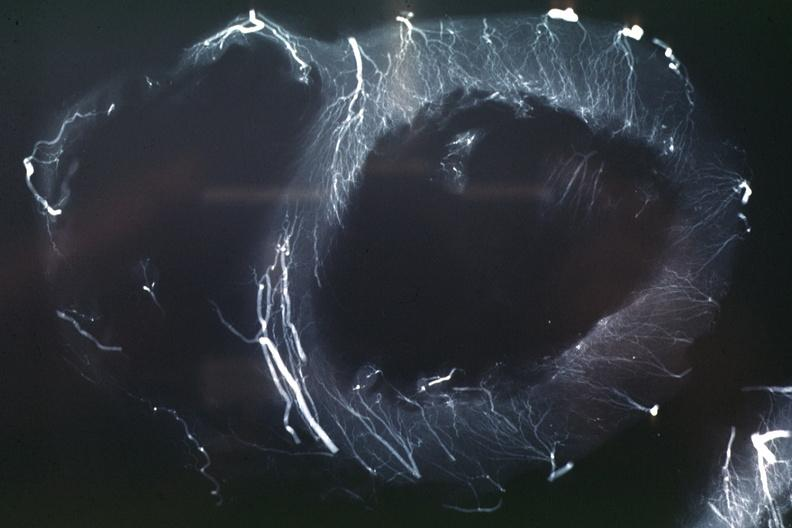what does this image show?
Answer the question using a single word or phrase. X-ray postmortinjection horizontal slice of left ventricle showing very well penetrating arteries 